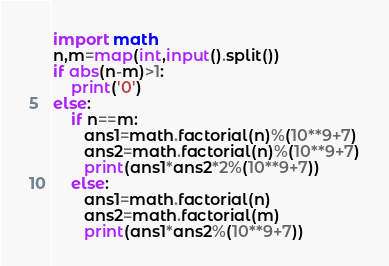<code> <loc_0><loc_0><loc_500><loc_500><_Python_>import math
n,m=map(int,input().split())
if abs(n-m)>1:
    print('0')
else:
    if n==m:
       ans1=math.factorial(n)%(10**9+7)
       ans2=math.factorial(n)%(10**9+7)
       print(ans1*ans2*2%(10**9+7))
    else:
       ans1=math.factorial(n)
       ans2=math.factorial(m)
       print(ans1*ans2%(10**9+7))
</code> 